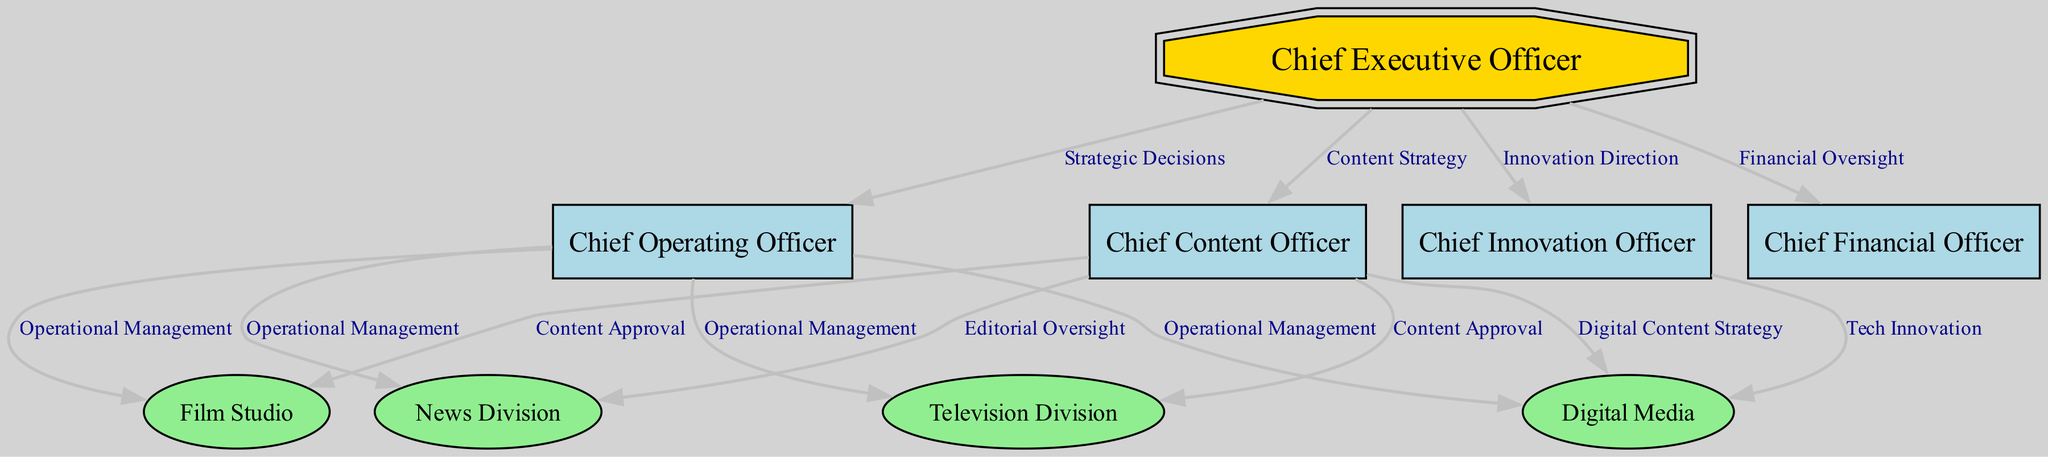What is the top node in the organizational chart? The top node represents the highest level of management in the organization, which is the Chief Executive Officer.
Answer: Chief Executive Officer How many divisions are managed under the Chief Operating Officer? By examining the edges leading from the Chief Operating Officer, we find there are four divisions namely Television, Film Studio, News Division, and Digital Media managed under the COO.
Answer: 4 What is the relationship between the Chief Executive Officer and the Chief Content Officer? According to the directed edge in the diagram, the Chief Executive Officer establishes the direction for content through a relationship labeled 'Content Strategy' with the Chief Content Officer.
Answer: Content Strategy Which division is connected to the Chief Innovation Officer? The directed edge from Chief Innovation Officer leads exclusively to the Digital Media division, showing that the CINO focuses on technological advancements in this area.
Answer: Digital Media What is the role of the Chief Financial Officer in the decision-making process? The Chief Financial Officer's role in the organizational structure is tied to providing oversight over financial matters, indicated by the directed edge labeled 'Financial Oversight' going from the CEO to the CFO.
Answer: Financial Oversight What type of content does the Chief Content Officer oversee in the News Division? The CCO has a relationship with the News Division indicated by 'Editorial Oversight,' which implies that the Chief Content Officer oversees editorial content production and quality in that division.
Answer: Editorial Oversight How many total nodes are included in the diagram? By counting all unique nodes in the organizational structure, we determine that there are a total of nine nodes, including the CEO, COO, CFO, CCO, CINO, and the four divisions.
Answer: 9 What is the function of the edges labeled 'Operational Management'? The edges labeled 'Operational Management' indicate that the Chief Operating Officer is responsible for the operational functions and activities of all four divisions, delineating the COO's managerial oversight in those areas.
Answer: Operational Management Which role is responsible for Tech Innovation? The directed edge shows that the Chief Innovation Officer is explicitly responsible for Tech Innovation relating to the Digital Media division, emphasizing their role in integrating technology advancements.
Answer: Chief Innovation Officer 